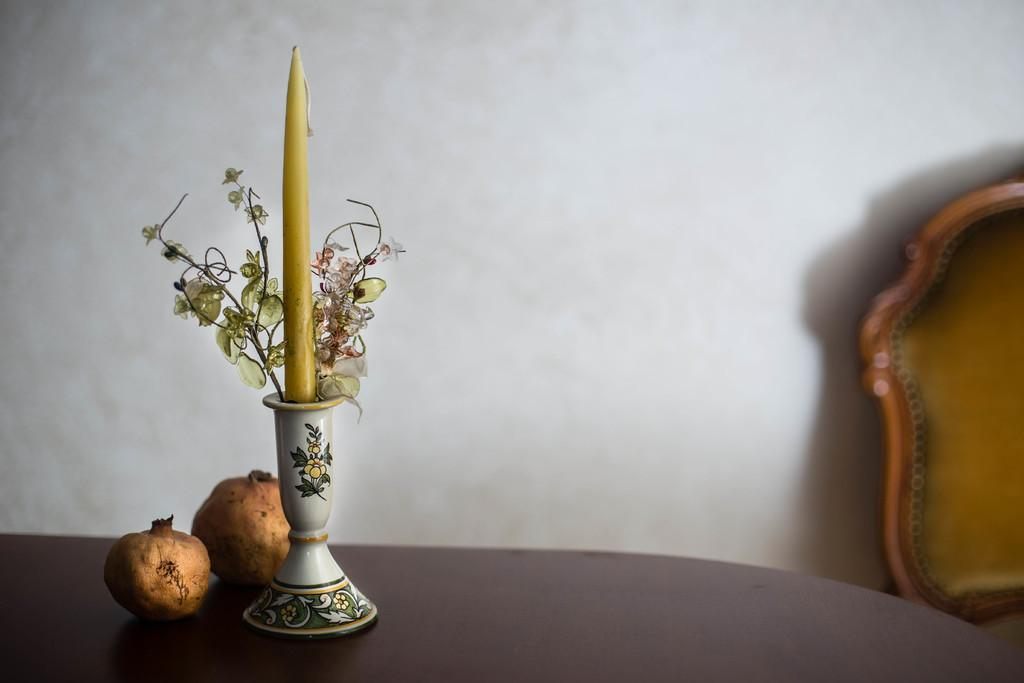What is on the table in the image? There is a flower vase on the table. Are there any other objects on the table besides the vase? Yes, there are two other fruits on the table. What can be seen in the background of the image? There is a white color wall and a chair in the background. How many clovers are on the table in the image? There are no clovers present in the image. What is the temperature of the ice in the image? There is no ice present in the image. 